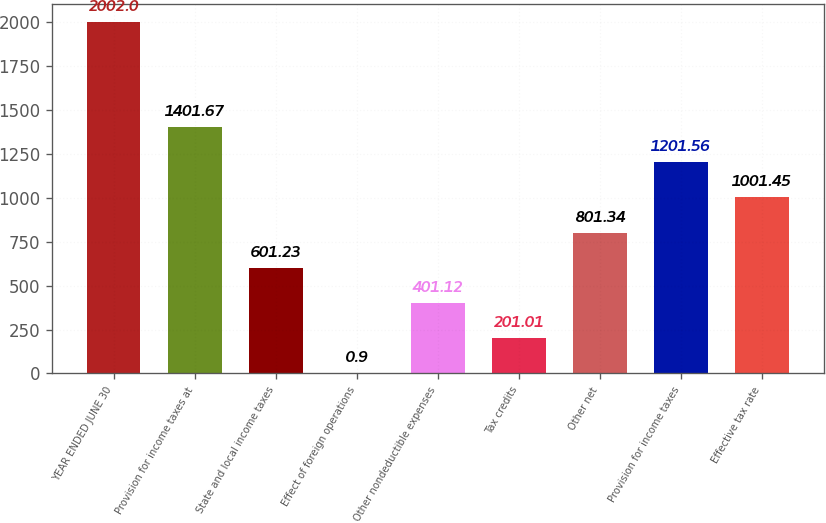Convert chart. <chart><loc_0><loc_0><loc_500><loc_500><bar_chart><fcel>YEAR ENDED JUNE 30<fcel>Provision for income taxes at<fcel>State and local income taxes<fcel>Effect of foreign operations<fcel>Other nondeductible expenses<fcel>Tax credits<fcel>Other net<fcel>Provision for income taxes<fcel>Effective tax rate<nl><fcel>2002<fcel>1401.67<fcel>601.23<fcel>0.9<fcel>401.12<fcel>201.01<fcel>801.34<fcel>1201.56<fcel>1001.45<nl></chart> 